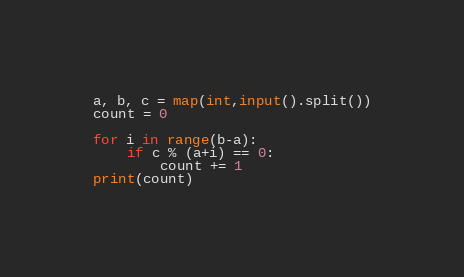<code> <loc_0><loc_0><loc_500><loc_500><_Python_>a, b, c = map(int,input().split())
count = 0

for i in range(b-a):
    if c % (a+i) == 0:
        count += 1
print(count)
</code> 